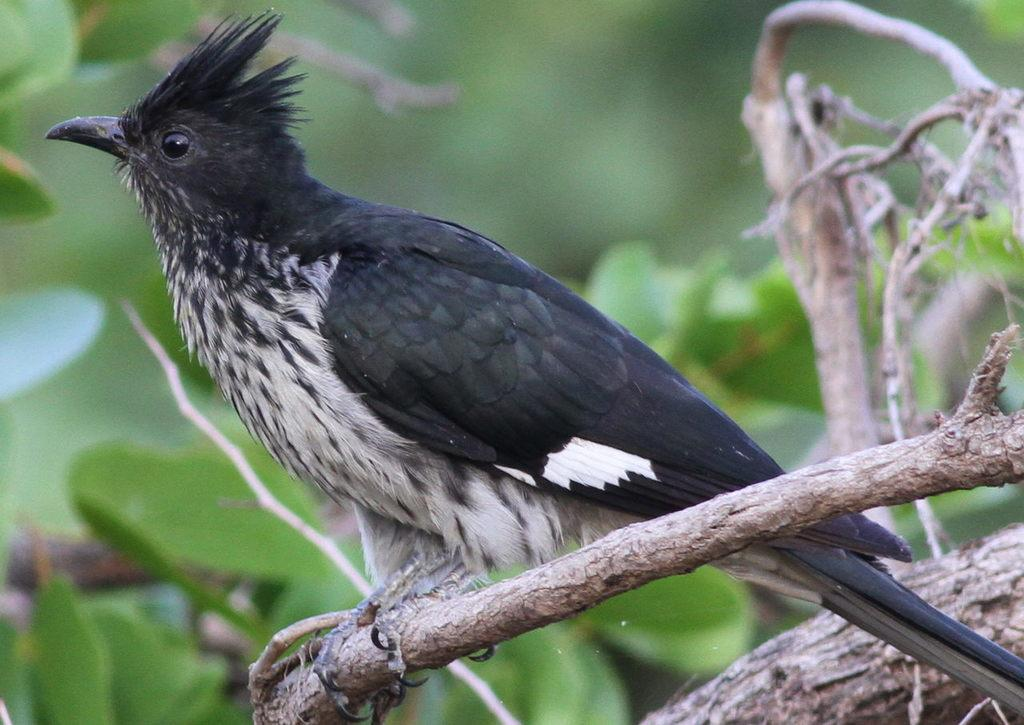What type of animal can be seen in the image? There is a bird in the image. Where is the bird located? The bird is on a branch. What can be seen in the background of the image? There are branches with leaves in the background of the image. How would you describe the background of the image? The background of the image is blurry. Can you see the creature kicking the ball in the image? There is no creature or ball present in the image; it features a bird on a branch with a blurry background. 